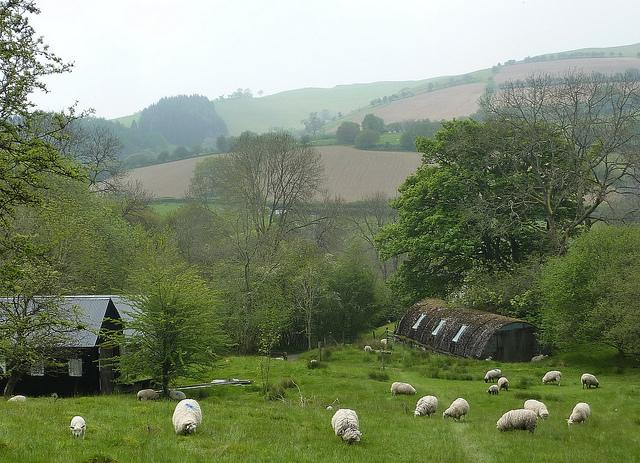What building material is the longhouse next to the sheep? wood 